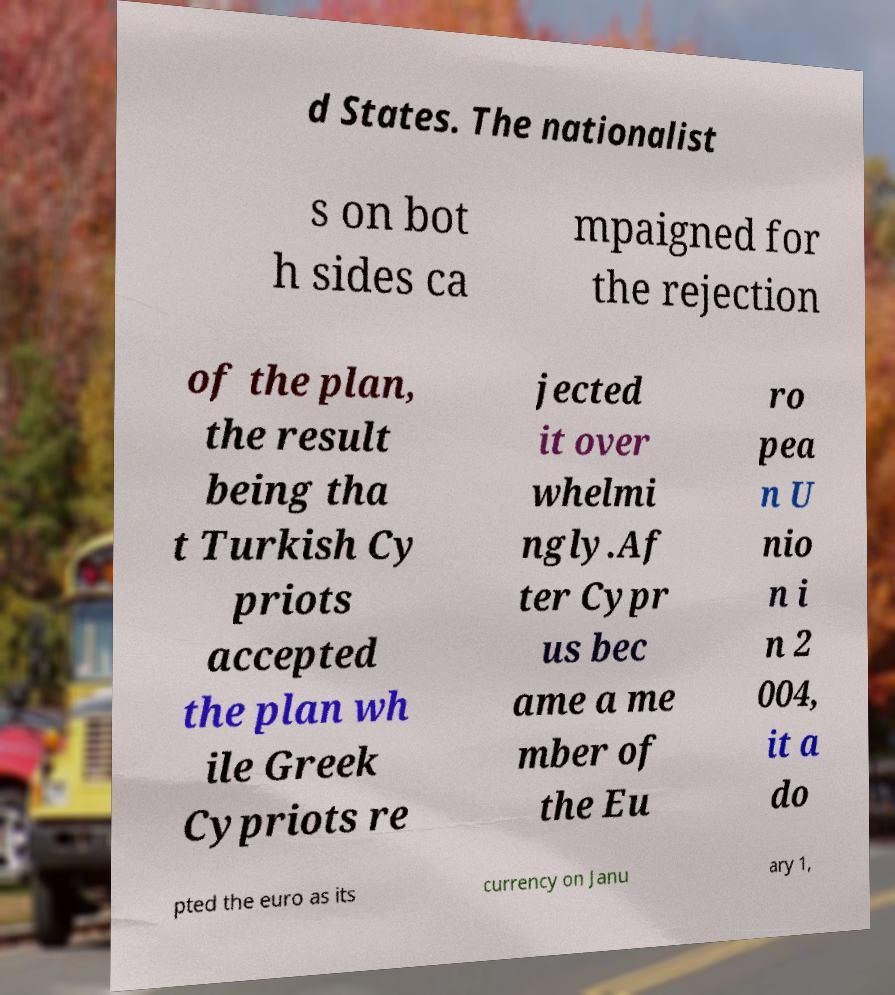Could you extract and type out the text from this image? d States. The nationalist s on bot h sides ca mpaigned for the rejection of the plan, the result being tha t Turkish Cy priots accepted the plan wh ile Greek Cypriots re jected it over whelmi ngly.Af ter Cypr us bec ame a me mber of the Eu ro pea n U nio n i n 2 004, it a do pted the euro as its currency on Janu ary 1, 